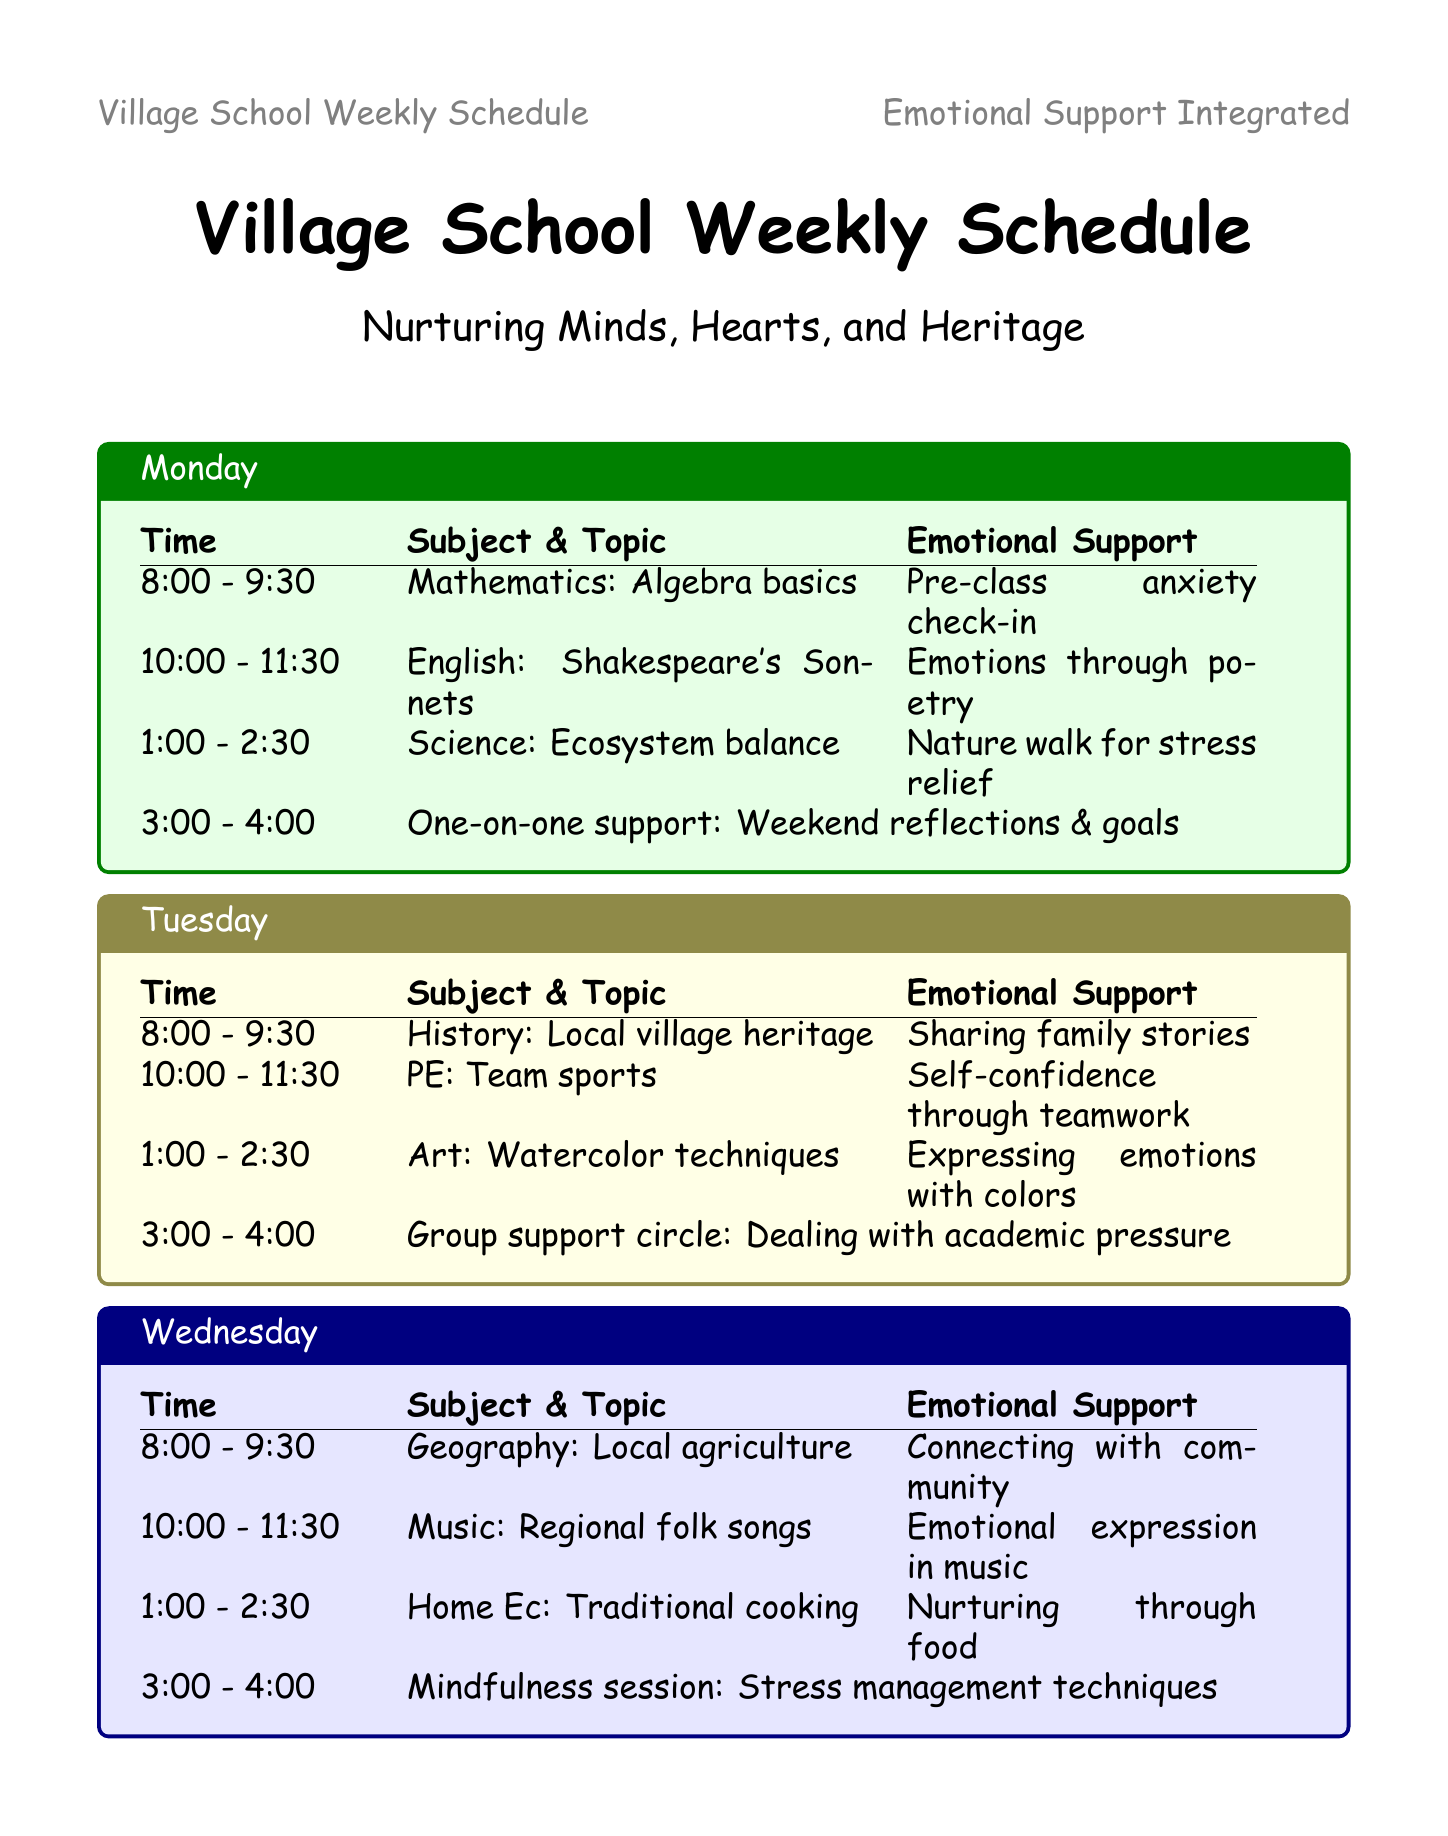What time does the Mathematics class start on Monday? The document specifies the time of the Mathematics class on Monday to be from 8:00 AM.
Answer: 8:00 AM What emotional support is provided during the English Literature class? During the English Literature class, the emotional support involves a group discussion on expressing emotions through poetry.
Answer: Group discussion on expressing emotions through poetry Which day has a session dedicated to dealing with academic pressure? The schedule mentions a group emotional support circle that focuses on dealing with academic pressure occurring on Tuesday.
Answer: Tuesday What is the focus of the one-on-one emotional support sessions? The focus for the one-on-one emotional support sessions is on weekend reflections and goal setting.
Answer: Weekend reflections and goal setting How many activities are scheduled on Friday from 8:00 AM to 2:30 PM? On Friday, the schedule lists three activities before 3:00 PM, covering Economics, Drama, and Career Guidance.
Answer: Three What type of session is held at 3:00 PM on Thursday? The activity scheduled for 3:00 PM on Thursday is peer support training focusing on building empathy and listening skills.
Answer: Peer support training Who provides after-school counseling according to the additional support resources? Mrs. Sharma is the contact person for after-school counseling at the Village Community Center.
Answer: Mrs. Sharma What emotional support is offered during the Friday Drama class? The emotional support for the Drama class on Friday involves exploring and expressing emotions through acting.
Answer: Exploring and expressing emotions through acting 